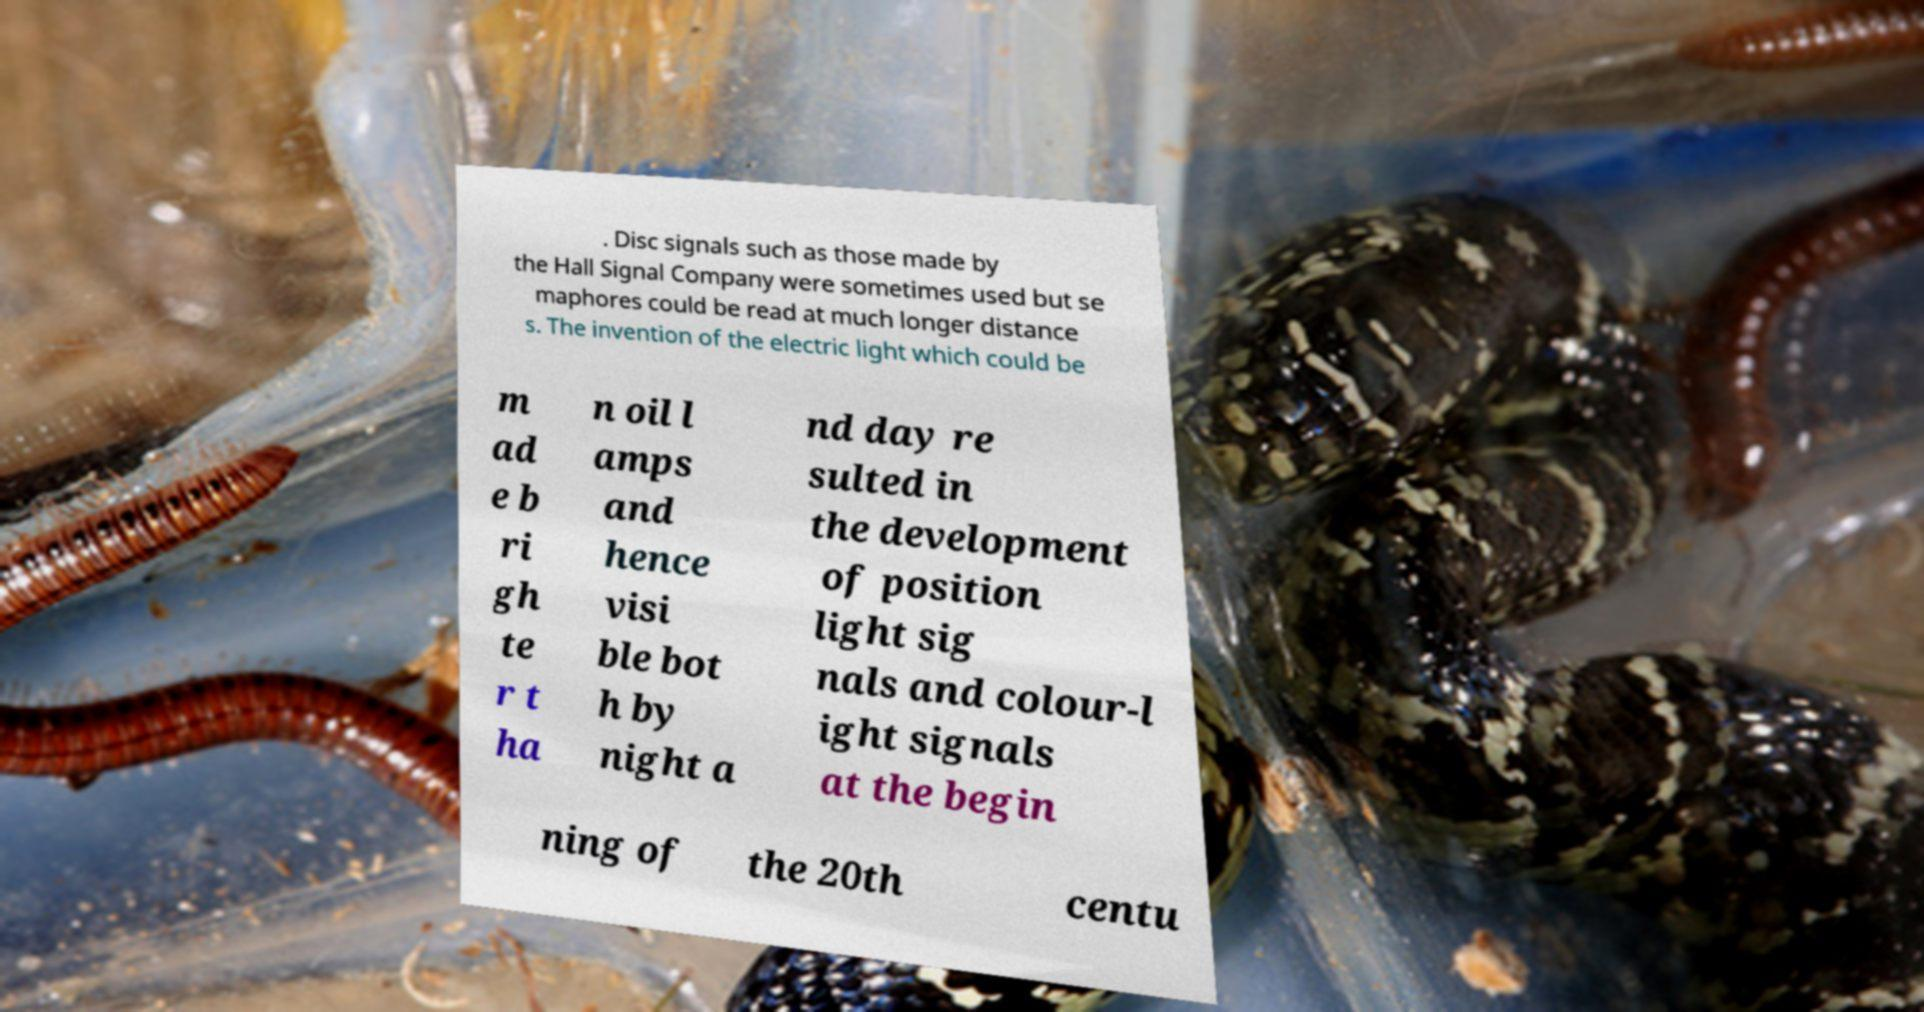Can you read and provide the text displayed in the image?This photo seems to have some interesting text. Can you extract and type it out for me? . Disc signals such as those made by the Hall Signal Company were sometimes used but se maphores could be read at much longer distance s. The invention of the electric light which could be m ad e b ri gh te r t ha n oil l amps and hence visi ble bot h by night a nd day re sulted in the development of position light sig nals and colour-l ight signals at the begin ning of the 20th centu 